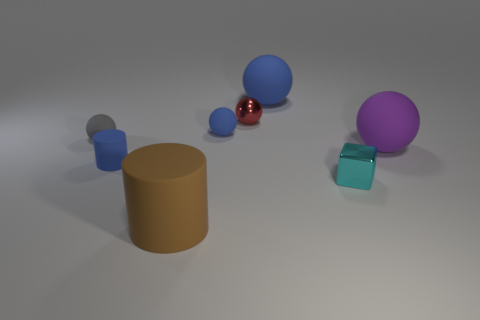Subtract all purple rubber spheres. How many spheres are left? 4 Subtract all gray spheres. How many spheres are left? 4 Subtract all purple balls. Subtract all green cubes. How many balls are left? 4 Add 1 red shiny things. How many objects exist? 9 Subtract all cylinders. How many objects are left? 6 Add 3 red shiny spheres. How many red shiny spheres exist? 4 Subtract 1 blue balls. How many objects are left? 7 Subtract all blue metallic spheres. Subtract all small gray matte balls. How many objects are left? 7 Add 3 tiny gray things. How many tiny gray things are left? 4 